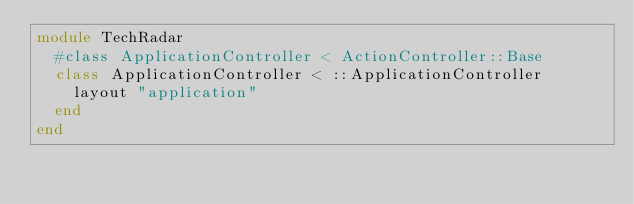<code> <loc_0><loc_0><loc_500><loc_500><_Ruby_>module TechRadar
  #class ApplicationController < ActionController::Base
  class ApplicationController < ::ApplicationController
    layout "application"
  end
end
</code> 